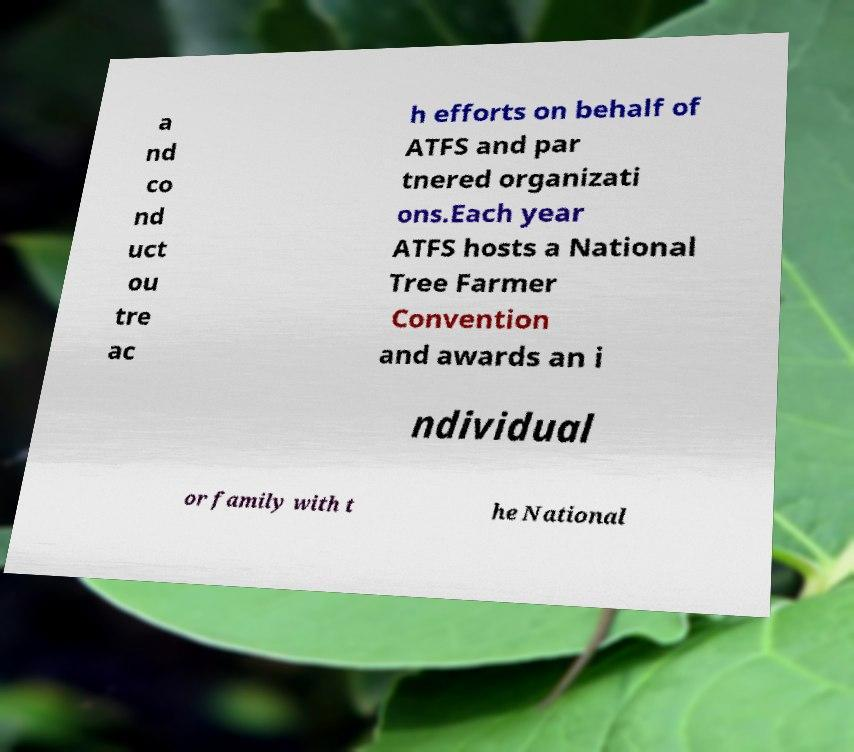Can you accurately transcribe the text from the provided image for me? a nd co nd uct ou tre ac h efforts on behalf of ATFS and par tnered organizati ons.Each year ATFS hosts a National Tree Farmer Convention and awards an i ndividual or family with t he National 